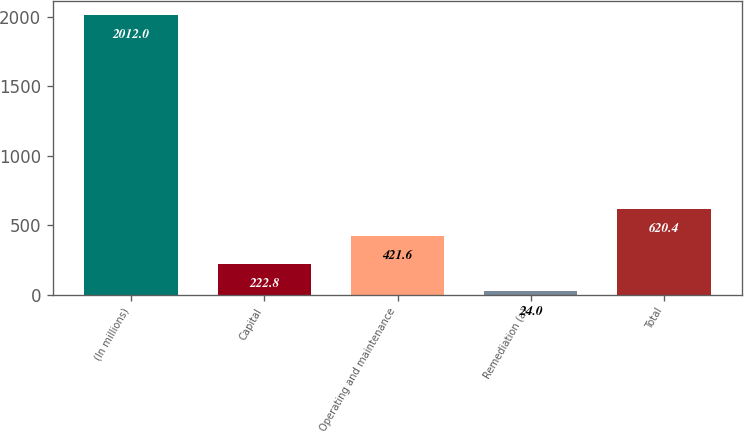Convert chart. <chart><loc_0><loc_0><loc_500><loc_500><bar_chart><fcel>(In millions)<fcel>Capital<fcel>Operating and maintenance<fcel>Remediation (a)<fcel>Total<nl><fcel>2012<fcel>222.8<fcel>421.6<fcel>24<fcel>620.4<nl></chart> 